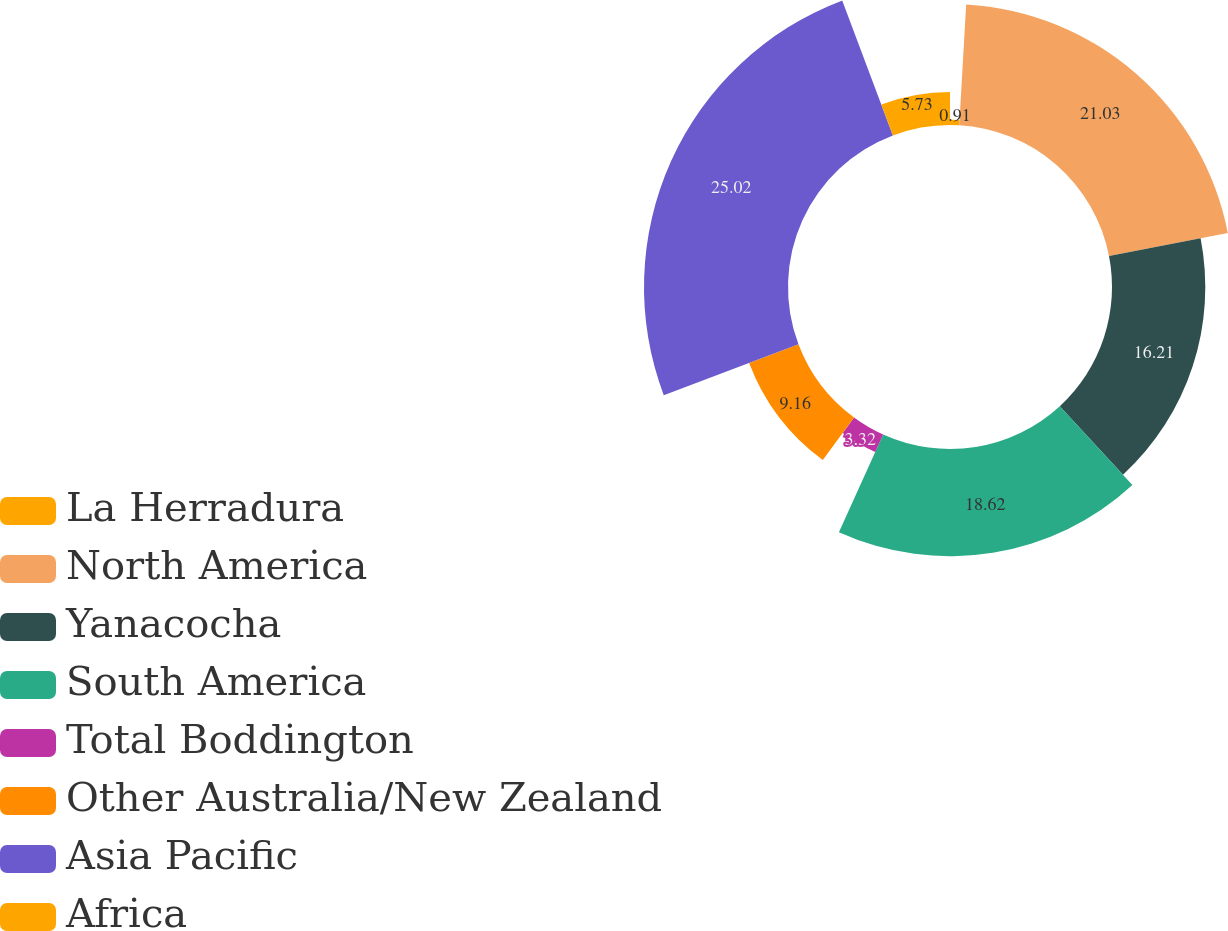Convert chart. <chart><loc_0><loc_0><loc_500><loc_500><pie_chart><fcel>La Herradura<fcel>North America<fcel>Yanacocha<fcel>South America<fcel>Total Boddington<fcel>Other Australia/New Zealand<fcel>Asia Pacific<fcel>Africa<nl><fcel>0.91%<fcel>21.03%<fcel>16.21%<fcel>18.62%<fcel>3.32%<fcel>9.16%<fcel>25.02%<fcel>5.73%<nl></chart> 